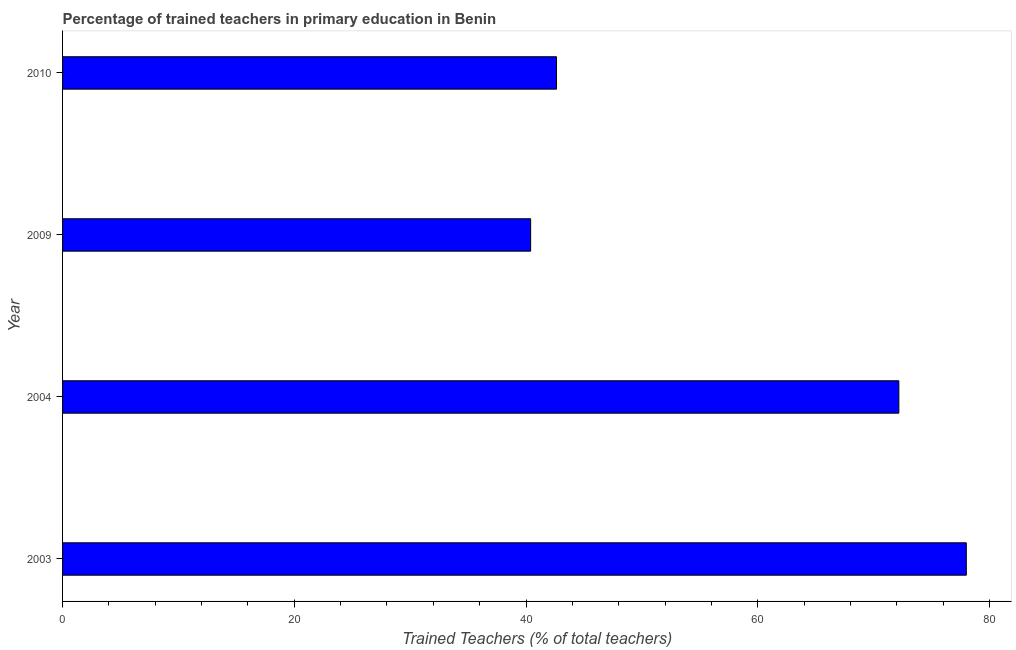Does the graph contain any zero values?
Offer a very short reply. No. What is the title of the graph?
Offer a very short reply. Percentage of trained teachers in primary education in Benin. What is the label or title of the X-axis?
Your answer should be compact. Trained Teachers (% of total teachers). What is the percentage of trained teachers in 2010?
Your answer should be very brief. 42.63. Across all years, what is the maximum percentage of trained teachers?
Provide a short and direct response. 78. Across all years, what is the minimum percentage of trained teachers?
Ensure brevity in your answer.  40.4. In which year was the percentage of trained teachers maximum?
Give a very brief answer. 2003. In which year was the percentage of trained teachers minimum?
Your answer should be compact. 2009. What is the sum of the percentage of trained teachers?
Offer a terse response. 233.21. What is the difference between the percentage of trained teachers in 2003 and 2004?
Your response must be concise. 5.82. What is the average percentage of trained teachers per year?
Make the answer very short. 58.3. What is the median percentage of trained teachers?
Your answer should be compact. 57.4. In how many years, is the percentage of trained teachers greater than 36 %?
Your answer should be very brief. 4. Do a majority of the years between 2010 and 2004 (inclusive) have percentage of trained teachers greater than 28 %?
Your answer should be very brief. Yes. What is the ratio of the percentage of trained teachers in 2004 to that in 2010?
Give a very brief answer. 1.69. Is the percentage of trained teachers in 2003 less than that in 2009?
Ensure brevity in your answer.  No. What is the difference between the highest and the second highest percentage of trained teachers?
Offer a very short reply. 5.82. Is the sum of the percentage of trained teachers in 2003 and 2004 greater than the maximum percentage of trained teachers across all years?
Your response must be concise. Yes. What is the difference between the highest and the lowest percentage of trained teachers?
Make the answer very short. 37.6. How many bars are there?
Offer a terse response. 4. Are all the bars in the graph horizontal?
Make the answer very short. Yes. How many years are there in the graph?
Provide a short and direct response. 4. What is the difference between two consecutive major ticks on the X-axis?
Ensure brevity in your answer.  20. Are the values on the major ticks of X-axis written in scientific E-notation?
Offer a very short reply. No. What is the Trained Teachers (% of total teachers) of 2003?
Your answer should be very brief. 78. What is the Trained Teachers (% of total teachers) of 2004?
Provide a succinct answer. 72.18. What is the Trained Teachers (% of total teachers) of 2009?
Offer a terse response. 40.4. What is the Trained Teachers (% of total teachers) in 2010?
Provide a succinct answer. 42.63. What is the difference between the Trained Teachers (% of total teachers) in 2003 and 2004?
Ensure brevity in your answer.  5.82. What is the difference between the Trained Teachers (% of total teachers) in 2003 and 2009?
Give a very brief answer. 37.6. What is the difference between the Trained Teachers (% of total teachers) in 2003 and 2010?
Your answer should be very brief. 35.37. What is the difference between the Trained Teachers (% of total teachers) in 2004 and 2009?
Ensure brevity in your answer.  31.78. What is the difference between the Trained Teachers (% of total teachers) in 2004 and 2010?
Ensure brevity in your answer.  29.55. What is the difference between the Trained Teachers (% of total teachers) in 2009 and 2010?
Keep it short and to the point. -2.23. What is the ratio of the Trained Teachers (% of total teachers) in 2003 to that in 2004?
Your answer should be compact. 1.08. What is the ratio of the Trained Teachers (% of total teachers) in 2003 to that in 2009?
Provide a succinct answer. 1.93. What is the ratio of the Trained Teachers (% of total teachers) in 2003 to that in 2010?
Your answer should be compact. 1.83. What is the ratio of the Trained Teachers (% of total teachers) in 2004 to that in 2009?
Make the answer very short. 1.79. What is the ratio of the Trained Teachers (% of total teachers) in 2004 to that in 2010?
Offer a terse response. 1.69. What is the ratio of the Trained Teachers (% of total teachers) in 2009 to that in 2010?
Ensure brevity in your answer.  0.95. 